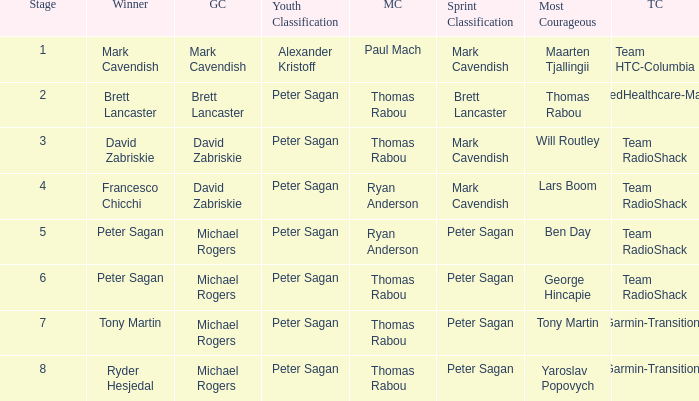When Yaroslav Popovych won most corageous, who won the mountains classification? Thomas Rabou. 